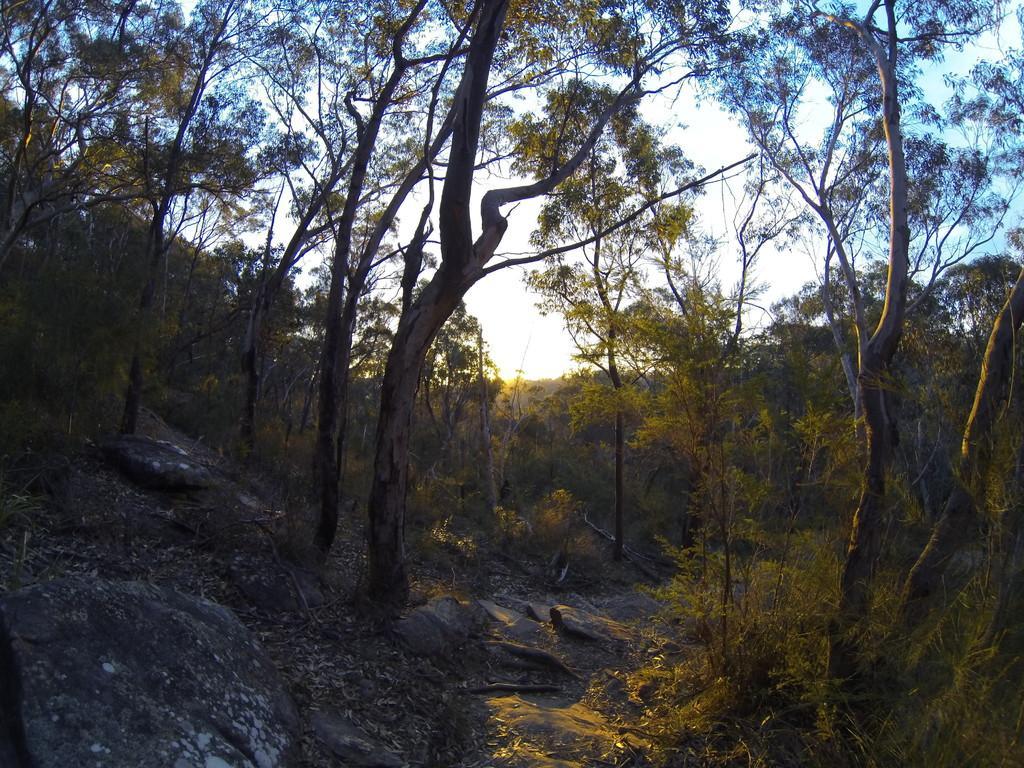Please provide a concise description of this image. In this image I can see few rocks, few trees, few leaves on the ground and the path. In the background I can see the sky. 